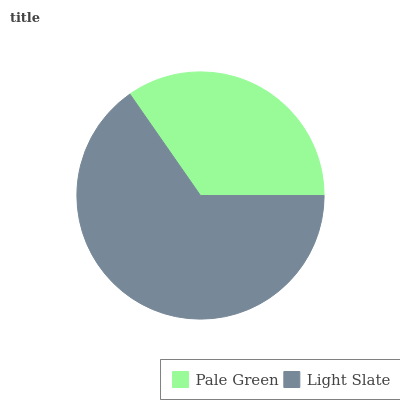Is Pale Green the minimum?
Answer yes or no. Yes. Is Light Slate the maximum?
Answer yes or no. Yes. Is Light Slate the minimum?
Answer yes or no. No. Is Light Slate greater than Pale Green?
Answer yes or no. Yes. Is Pale Green less than Light Slate?
Answer yes or no. Yes. Is Pale Green greater than Light Slate?
Answer yes or no. No. Is Light Slate less than Pale Green?
Answer yes or no. No. Is Light Slate the high median?
Answer yes or no. Yes. Is Pale Green the low median?
Answer yes or no. Yes. Is Pale Green the high median?
Answer yes or no. No. Is Light Slate the low median?
Answer yes or no. No. 